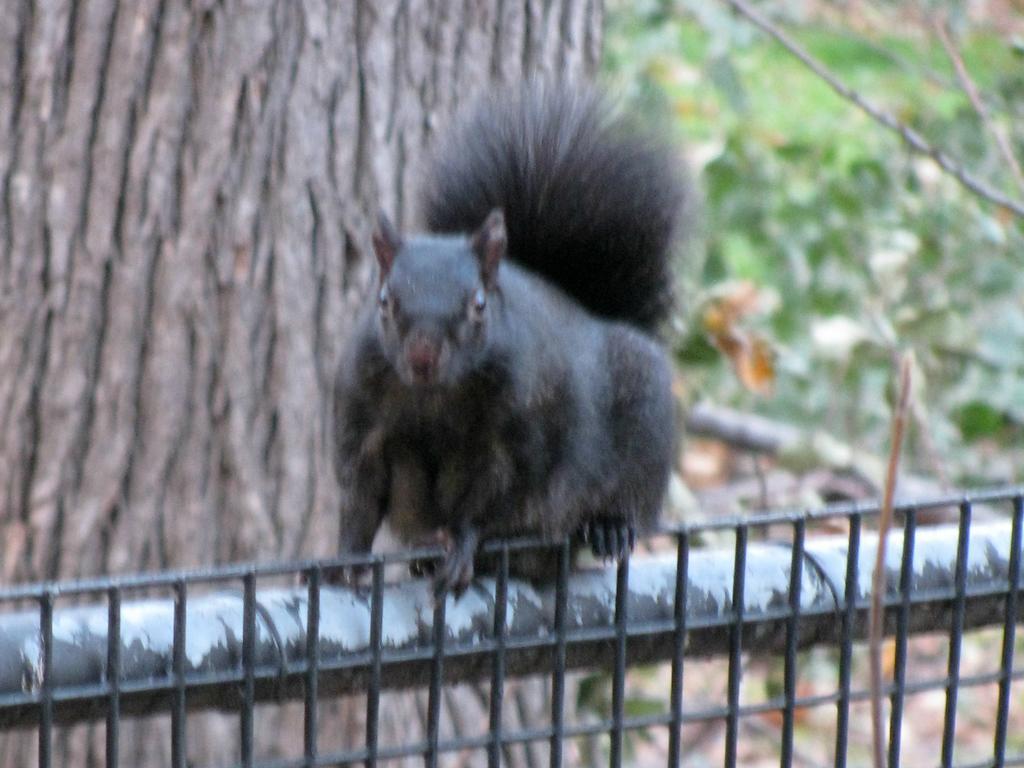How would you summarize this image in a sentence or two? This picture is clicked outside. In the center there is a black colored squirrel on the metal rods. In the background there is a trunk of a tree and we can see the green color objects seems to be the plants. 